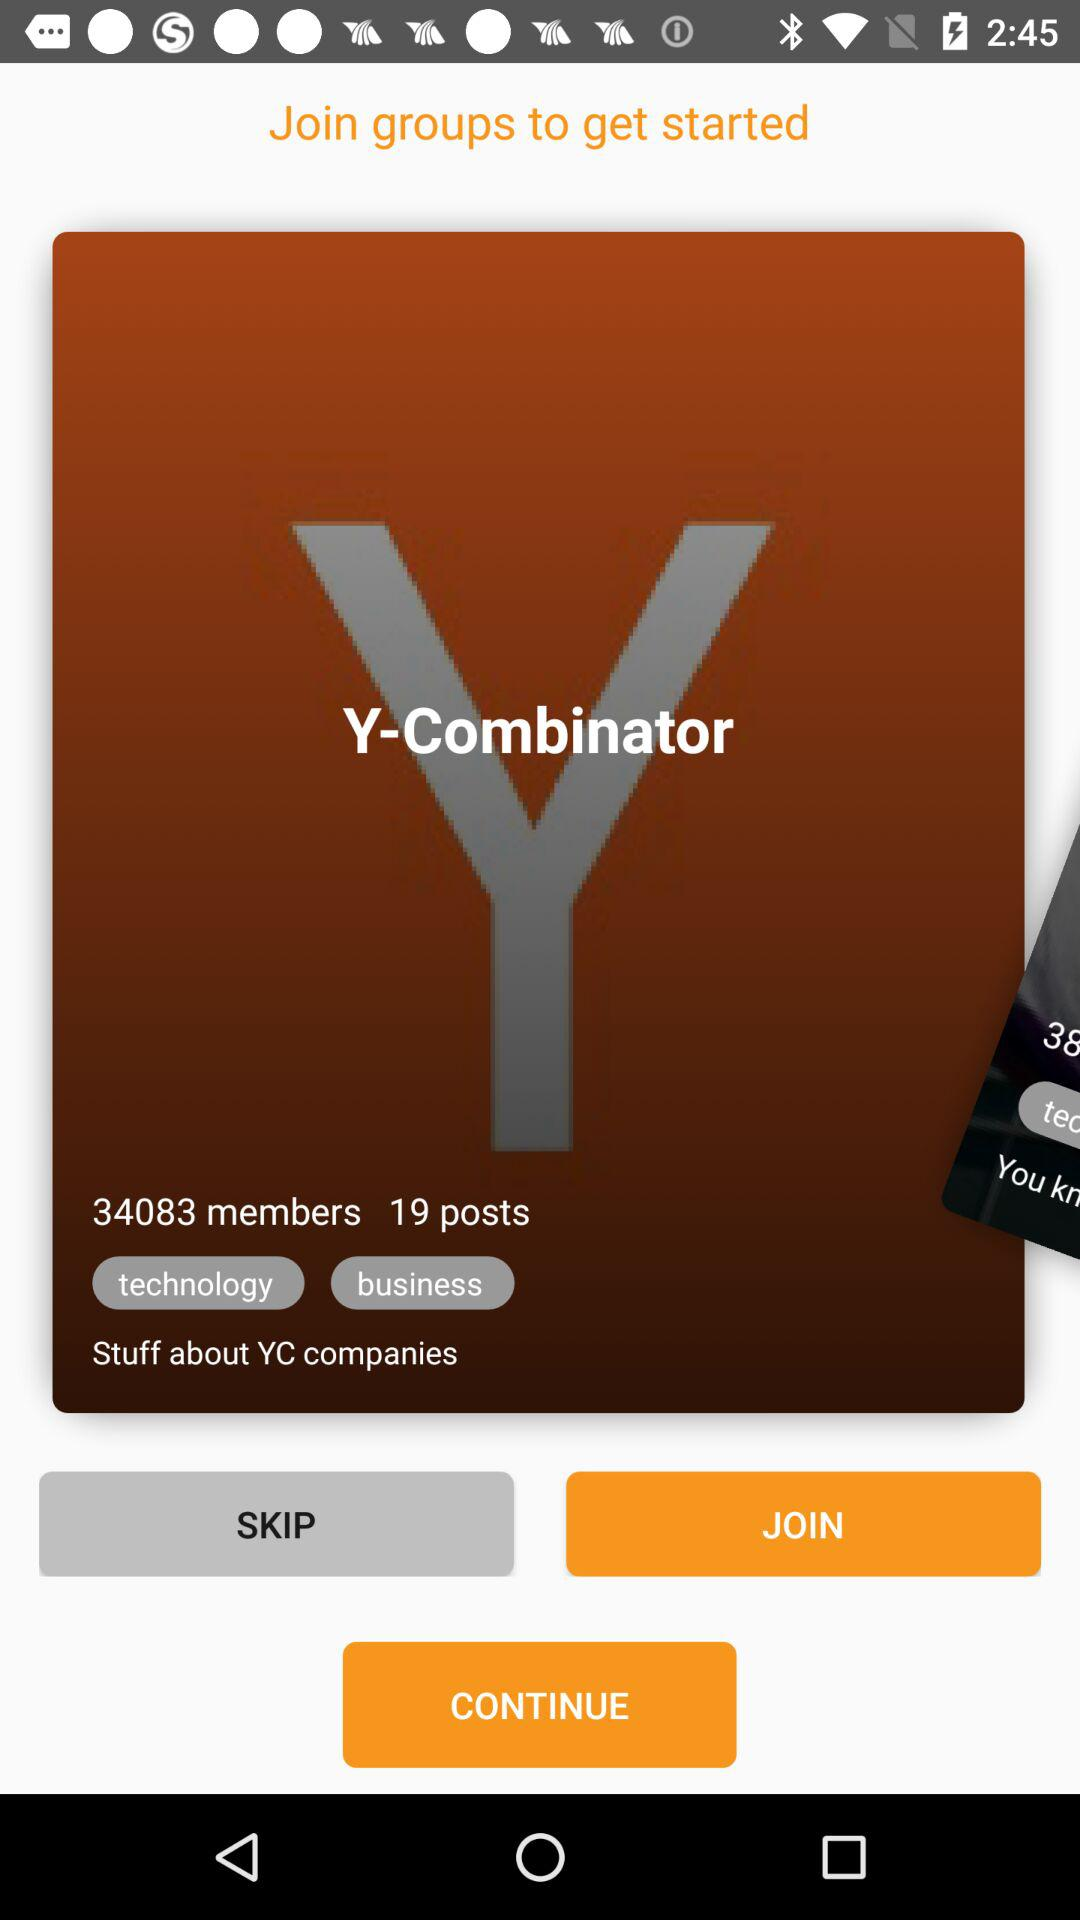How many members are shown? The shown members are 34083. 